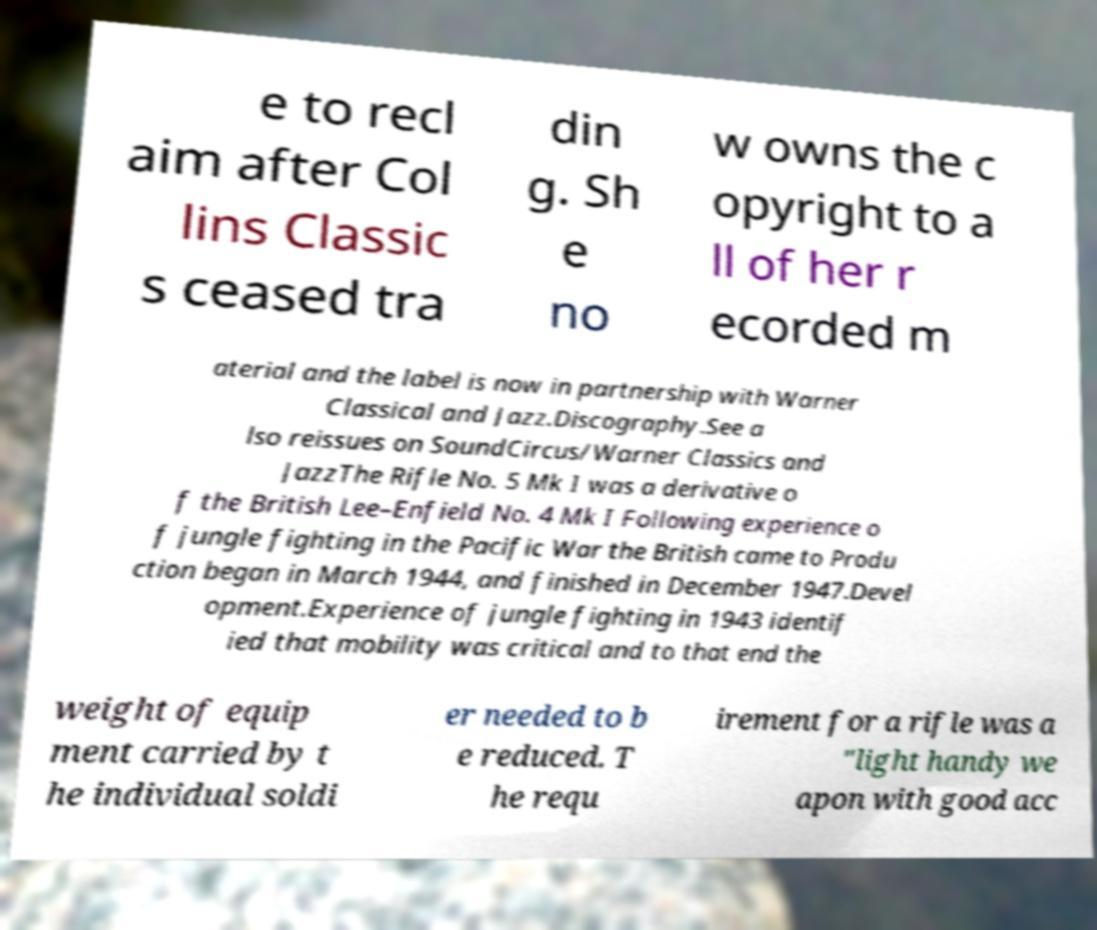Could you assist in decoding the text presented in this image and type it out clearly? e to recl aim after Col lins Classic s ceased tra din g. Sh e no w owns the c opyright to a ll of her r ecorded m aterial and the label is now in partnership with Warner Classical and Jazz.Discography.See a lso reissues on SoundCircus/Warner Classics and JazzThe Rifle No. 5 Mk I was a derivative o f the British Lee–Enfield No. 4 Mk I Following experience o f jungle fighting in the Pacific War the British came to Produ ction began in March 1944, and finished in December 1947.Devel opment.Experience of jungle fighting in 1943 identif ied that mobility was critical and to that end the weight of equip ment carried by t he individual soldi er needed to b e reduced. T he requ irement for a rifle was a "light handy we apon with good acc 